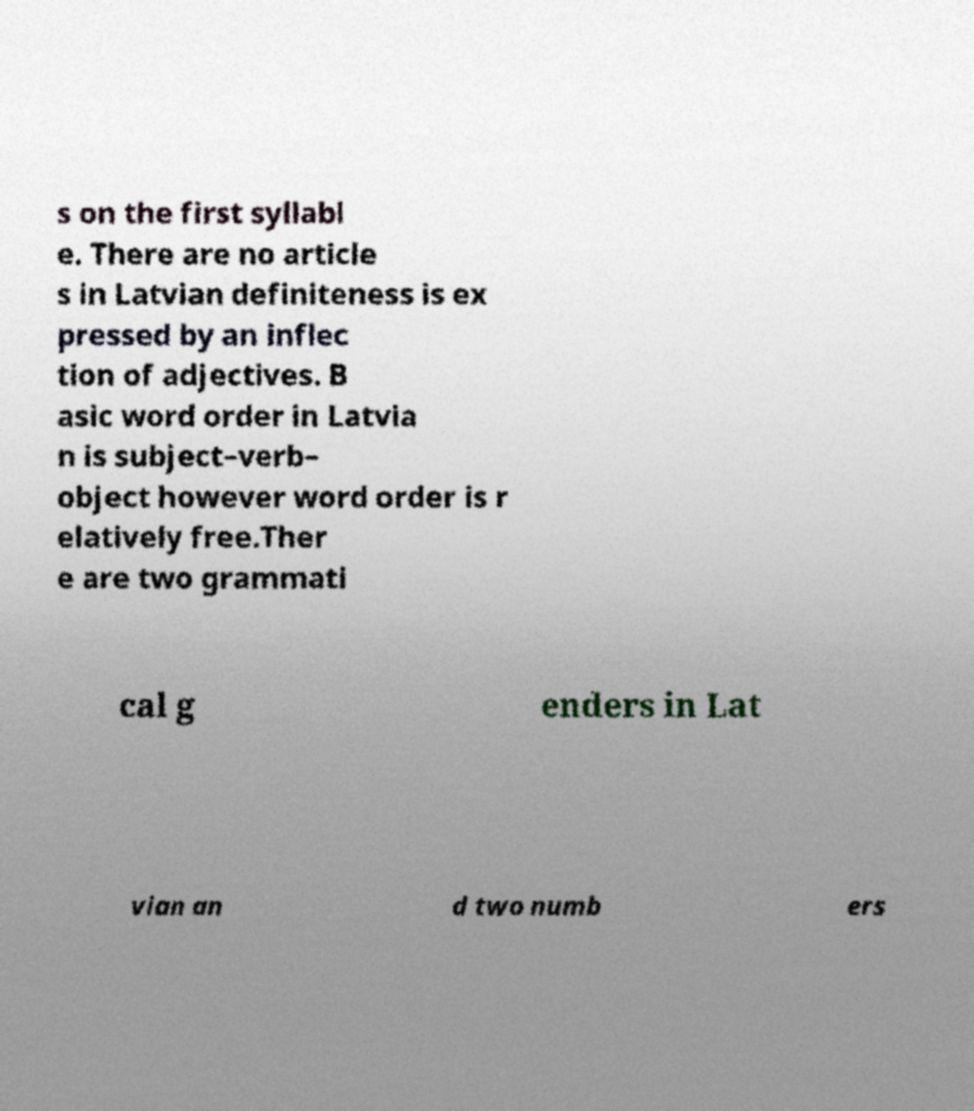Can you accurately transcribe the text from the provided image for me? s on the first syllabl e. There are no article s in Latvian definiteness is ex pressed by an inflec tion of adjectives. B asic word order in Latvia n is subject–verb– object however word order is r elatively free.Ther e are two grammati cal g enders in Lat vian an d two numb ers 